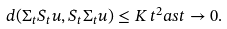<formula> <loc_0><loc_0><loc_500><loc_500>d ( \Sigma _ { t } S _ { t } u , S _ { t } \Sigma _ { t } u ) \leq K \, t ^ { 2 } a s t \to 0 .</formula> 